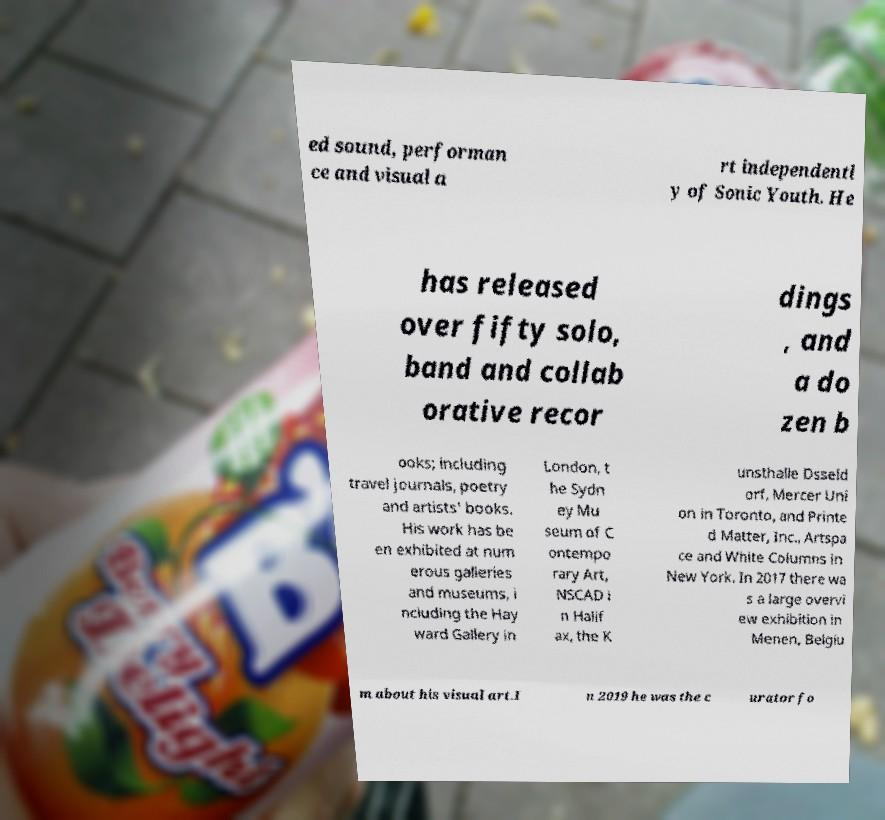Could you extract and type out the text from this image? ed sound, performan ce and visual a rt independentl y of Sonic Youth. He has released over fifty solo, band and collab orative recor dings , and a do zen b ooks; including travel journals, poetry and artists' books. His work has be en exhibited at num erous galleries and museums, i ncluding the Hay ward Gallery in London, t he Sydn ey Mu seum of C ontempo rary Art, NSCAD i n Halif ax, the K unsthalle Dsseld orf, Mercer Uni on in Toronto, and Printe d Matter, Inc., Artspa ce and White Columns in New York. In 2017 there wa s a large overvi ew exhibition in Menen, Belgiu m about his visual art.I n 2019 he was the c urator fo 